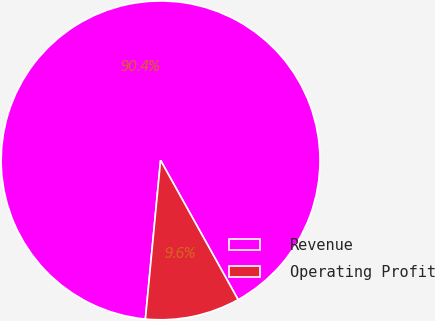Convert chart to OTSL. <chart><loc_0><loc_0><loc_500><loc_500><pie_chart><fcel>Revenue<fcel>Operating Profit<nl><fcel>90.4%<fcel>9.6%<nl></chart> 